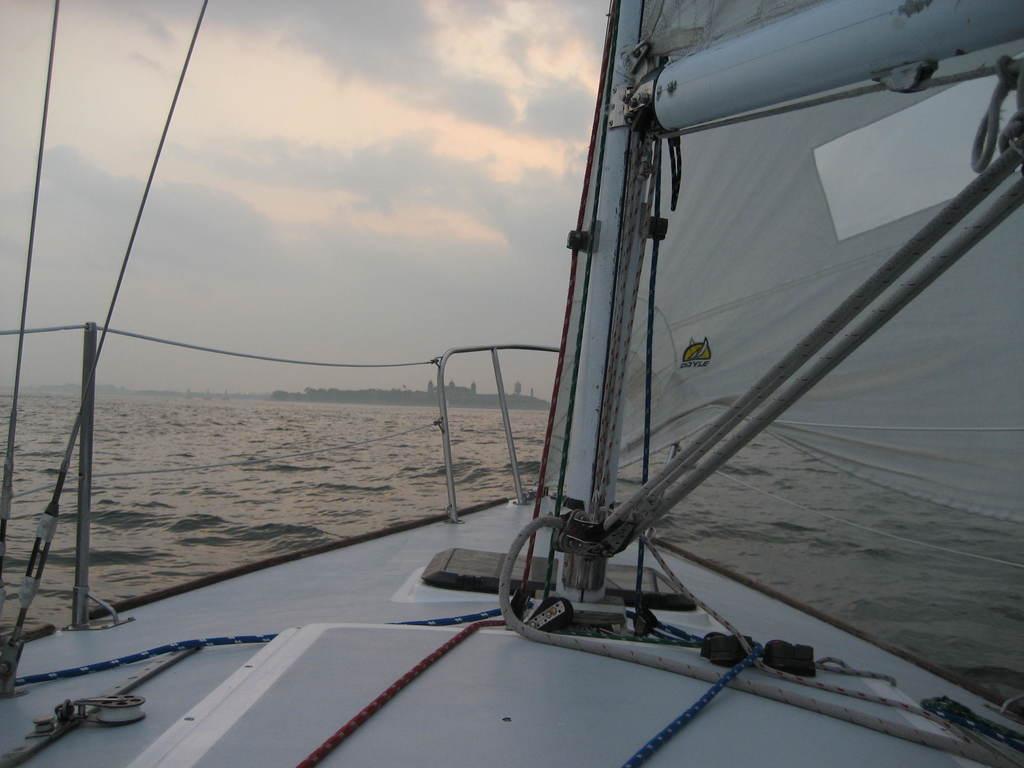Please provide a concise description of this image. In this image there is a ship in the water. At the background there are trees, building and sky. 